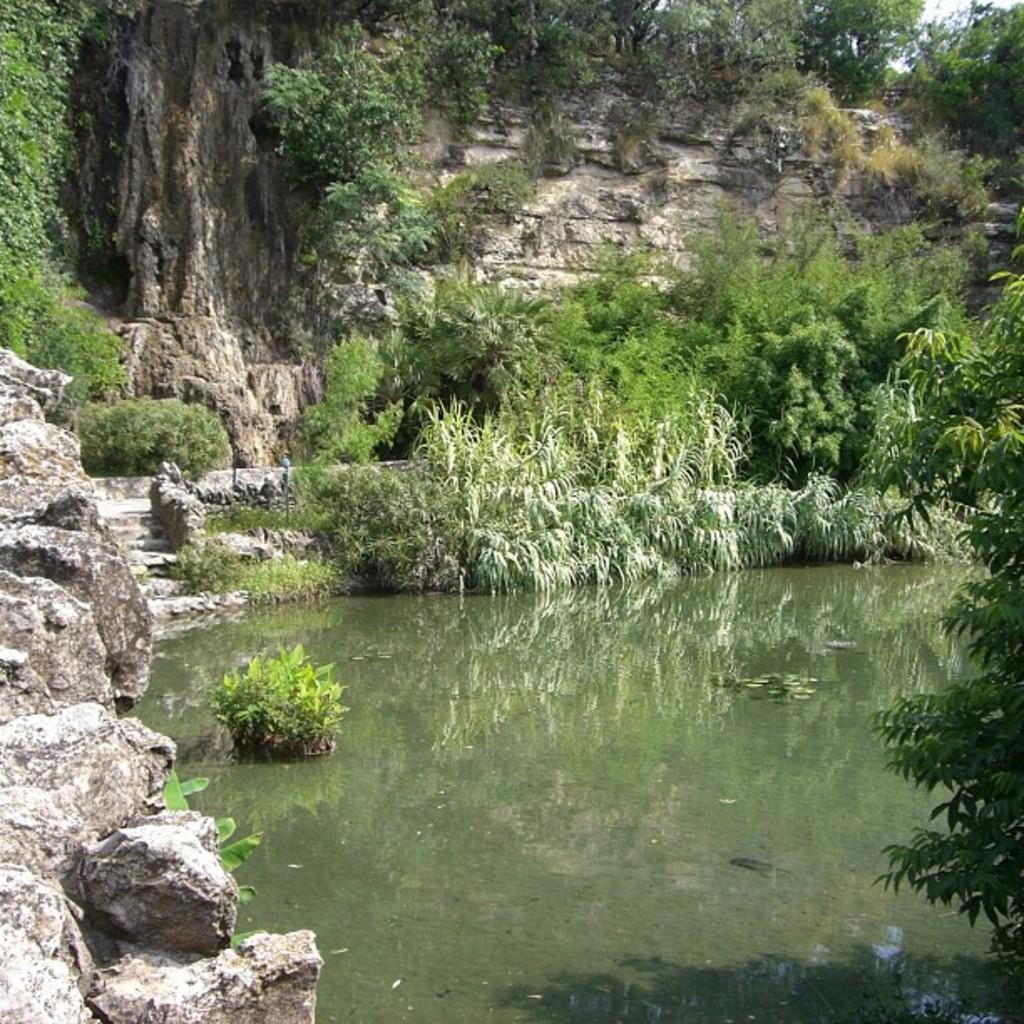What type of body of water is in the image? There is a lake in the image. What type of vegetation can be seen in the image? Bushes, shrubs, and trees are present in the image. What type of natural elements are visible in the image? Stones and rocks are visible in the image. What part of the natural environment is visible in the image? The sky is visible in the image. What type of metal is used to create the action in the image? There is no metal or action present in the image; it features a lake, vegetation, and natural elements. 